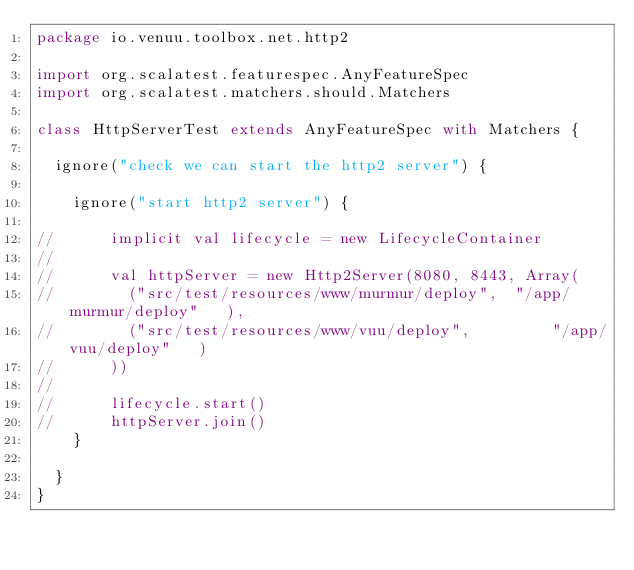<code> <loc_0><loc_0><loc_500><loc_500><_Scala_>package io.venuu.toolbox.net.http2

import org.scalatest.featurespec.AnyFeatureSpec
import org.scalatest.matchers.should.Matchers

class HttpServerTest extends AnyFeatureSpec with Matchers {

  ignore("check we can start the http2 server") {

    ignore("start http2 server") {

//      implicit val lifecycle = new LifecycleContainer
//
//      val httpServer = new Http2Server(8080, 8443, Array(
//        ("src/test/resources/www/murmur/deploy",  "/app/murmur/deploy"   ),
//        ("src/test/resources/www/vuu/deploy",         "/app/vuu/deploy"   )
//      ))
//
//      lifecycle.start()
//      httpServer.join()
    }

  }
}
</code> 